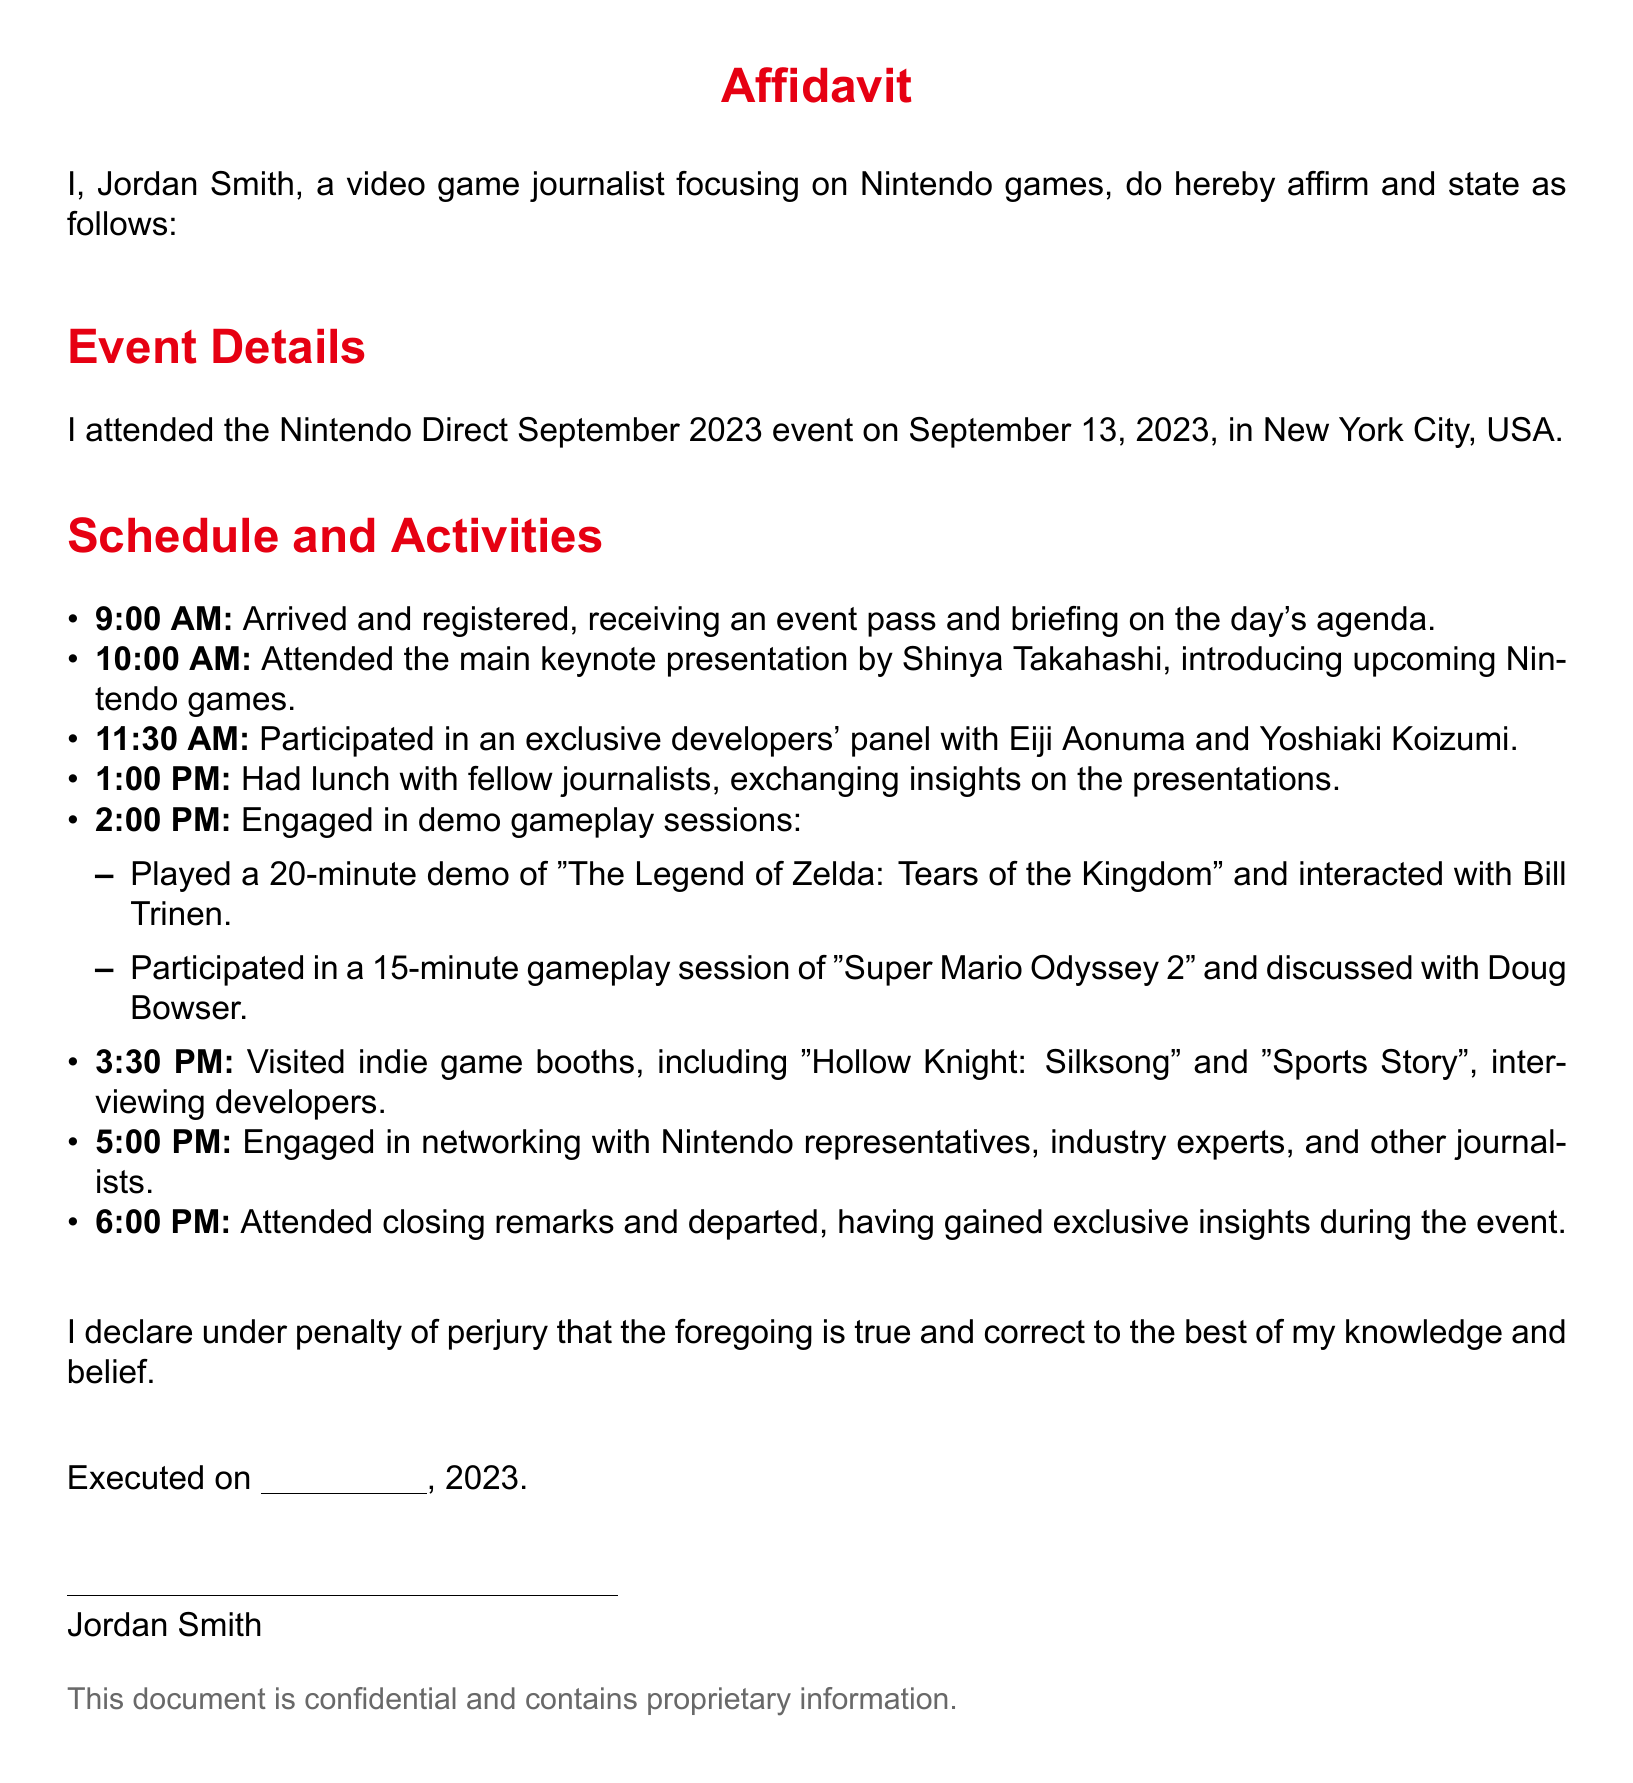What is the name of the event attended? The event is referred to as the Nintendo Direct September 2023 event.
Answer: Nintendo Direct September 2023 What date did the event take place? The affidavit states that the event occurred on September 13, 2023.
Answer: September 13, 2023 Who hosted the main keynote presentation? The document mentions Shinya Takahashi as the host of the main keynote presentation.
Answer: Shinya Takahashi What time did lunch with fellow journalists start? According to the schedule, lunch started at 1:00 PM.
Answer: 1:00 PM Which game had a 20-minute demo session? The affidavit specifies that "The Legend of Zelda: Tears of the Kingdom" was featured in the demo session.
Answer: The Legend of Zelda: Tears of the Kingdom Who did the attendee interact with during the demo gameplay sessions? The affidavit names Bill Trinen and Doug Bowser as individuals the attendee interacted with.
Answer: Bill Trinen and Doug Bowser What was one of the indie games visited? The document lists "Hollow Knight: Silksong" as one of the indie games visited.
Answer: Hollow Knight: Silksong What time did the attendee depart the event? The affidavit states that the attendee departed at 6:00 PM.
Answer: 6:00 PM What is the role of Jordan Smith? The document identifies Jordan Smith as a video game journalist focusing on Nintendo games.
Answer: Video game journalist focusing on Nintendo games 